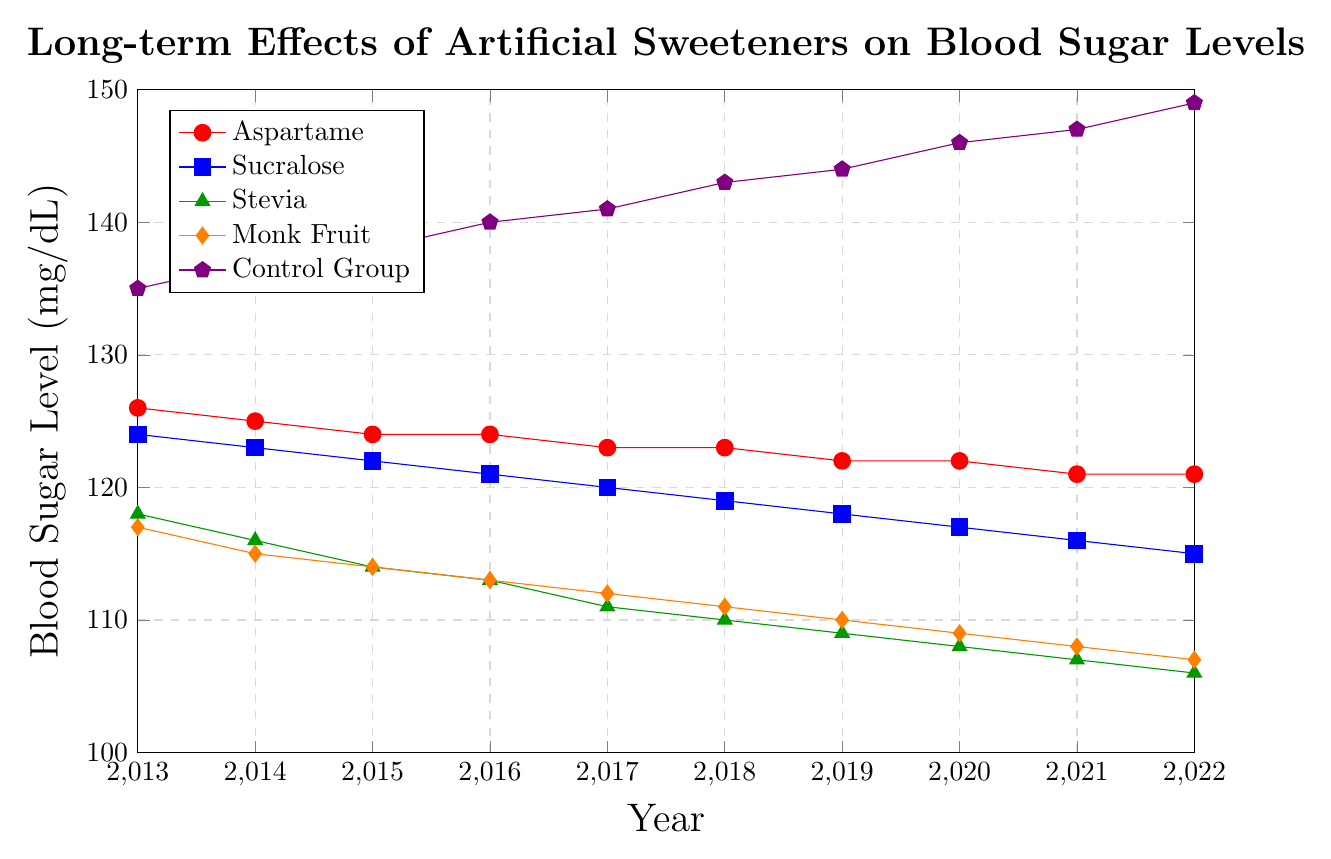What is the general trend of blood sugar levels in the Control Group over the 10-year period? The blood sugar levels in the Control Group show a consistent increasing trend from 135 mg/dL in 2013 to 149 mg/dL in 2022.
Answer: Increasing Which artificial sweetener shows the greatest reduction in blood sugar levels over the 10-year period? To find the greatest reduction, compare the blood sugar levels in 2013 and 2022 for each sweetener. Stevia reduces from 118 mg/dL to 106 mg/dL, which is a reduction of 12 mg/dL, the largest among the sweeteners.
Answer: Stevia Between 2013 and 2022, what is the total change in blood sugar level for individuals consuming Monk Fruit? The blood sugar level for Monk Fruit changes from 117 mg/dL in 2013 to 107 mg/dL in 2022, resulting in a reduction of 10 mg/dL.
Answer: -10 mg/dL How do the blood sugar levels with Aspartame in 2022 compare to those with the Control Group in the same year? In 2022, the blood sugar level for Aspartame is 121 mg/dL, whereas for the Control Group it is 149 mg/dL, showing Aspartame has a lower level.
Answer: Lower Which year shows the smallest difference between the blood sugar levels of Sucralose and the Control Group? Calculate the difference for each year. In 2013, the difference is 135-124=11; in 2014, it's 137-123=14; continue until 2022. The smallest difference is in 2013, which is 11 mg/dL.
Answer: 2013 By how much did the blood sugar levels change for Stevia from 2015 to 2018? In 2015, Stevia has a level of 114 mg/dL and in 2018, it drops to 110 mg/dL. The difference is 114 - 110 = 4 mg/dL.
Answer: -4 mg/dL If the trend continues, what is the expected blood sugar level for the Control Group in 2023? The trend in the Control Group's data shows a consistent increase. From 2021 to 2022, the level increased by 2 mg/dL (from 147 to 149). If the trend continues, the expected level for 2023 would be 149 + 2 = 151 mg/dL.
Answer: 151 mg/dL Which sweetener consistently maintains the lowest blood sugar levels throughout the 10-year period? Compare the blood sugar levels of each sweetener across all years. Stevia consistently has the lowest levels, beginning at 118 mg/dL in 2013 and ending at 106 mg/dL in 2022.
Answer: Stevia 